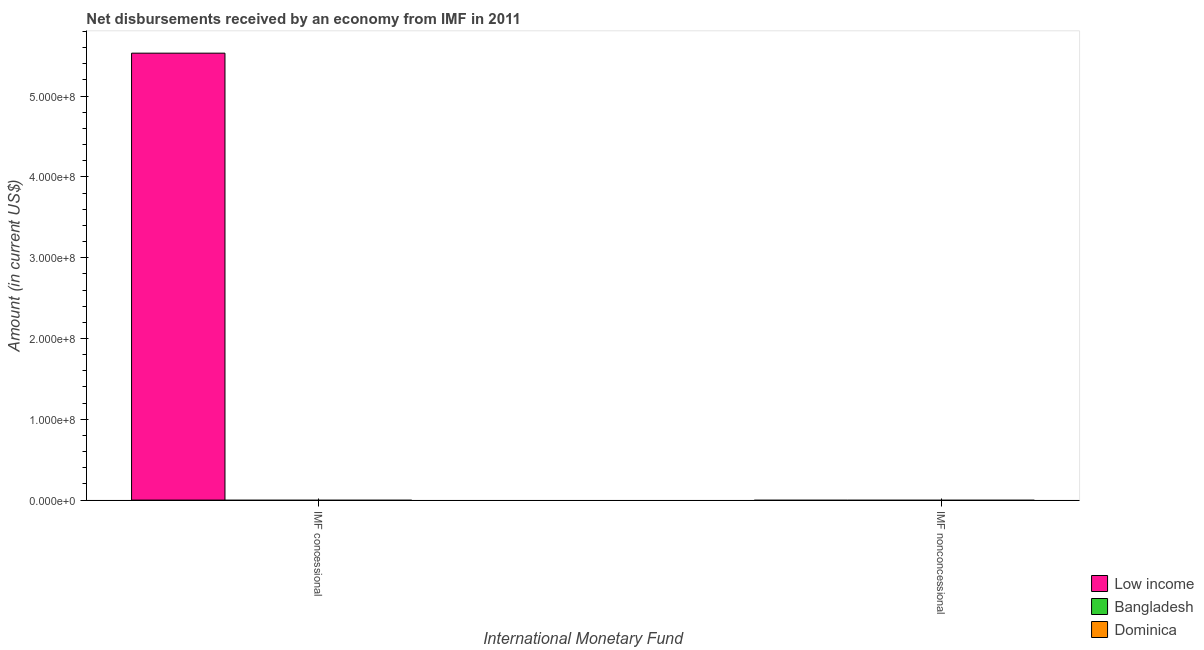How many different coloured bars are there?
Provide a short and direct response. 1. Are the number of bars per tick equal to the number of legend labels?
Give a very brief answer. No. Are the number of bars on each tick of the X-axis equal?
Give a very brief answer. No. How many bars are there on the 1st tick from the right?
Your answer should be compact. 0. What is the label of the 2nd group of bars from the left?
Provide a short and direct response. IMF nonconcessional. What is the net concessional disbursements from imf in Dominica?
Provide a succinct answer. 0. Across all countries, what is the maximum net concessional disbursements from imf?
Offer a terse response. 5.53e+08. Across all countries, what is the minimum net non concessional disbursements from imf?
Your answer should be compact. 0. What is the total net non concessional disbursements from imf in the graph?
Your answer should be compact. 0. What is the difference between the net concessional disbursements from imf in Low income and the net non concessional disbursements from imf in Bangladesh?
Ensure brevity in your answer.  5.53e+08. What is the average net concessional disbursements from imf per country?
Make the answer very short. 1.84e+08. In how many countries, is the net non concessional disbursements from imf greater than 420000000 US$?
Your answer should be compact. 0. In how many countries, is the net non concessional disbursements from imf greater than the average net non concessional disbursements from imf taken over all countries?
Provide a short and direct response. 0. How many bars are there?
Your response must be concise. 1. Are all the bars in the graph horizontal?
Your answer should be compact. No. Does the graph contain any zero values?
Keep it short and to the point. Yes. Does the graph contain grids?
Provide a succinct answer. No. How many legend labels are there?
Keep it short and to the point. 3. How are the legend labels stacked?
Provide a succinct answer. Vertical. What is the title of the graph?
Offer a very short reply. Net disbursements received by an economy from IMF in 2011. What is the label or title of the X-axis?
Give a very brief answer. International Monetary Fund. What is the Amount (in current US$) in Low income in IMF concessional?
Keep it short and to the point. 5.53e+08. What is the Amount (in current US$) in Bangladesh in IMF concessional?
Ensure brevity in your answer.  0. What is the Amount (in current US$) in Low income in IMF nonconcessional?
Provide a short and direct response. 0. What is the Amount (in current US$) of Bangladesh in IMF nonconcessional?
Give a very brief answer. 0. What is the Amount (in current US$) in Dominica in IMF nonconcessional?
Give a very brief answer. 0. Across all International Monetary Fund, what is the maximum Amount (in current US$) of Low income?
Provide a succinct answer. 5.53e+08. Across all International Monetary Fund, what is the minimum Amount (in current US$) in Low income?
Your answer should be very brief. 0. What is the total Amount (in current US$) in Low income in the graph?
Your response must be concise. 5.53e+08. What is the total Amount (in current US$) in Bangladesh in the graph?
Provide a short and direct response. 0. What is the average Amount (in current US$) of Low income per International Monetary Fund?
Provide a succinct answer. 2.77e+08. What is the average Amount (in current US$) of Dominica per International Monetary Fund?
Your answer should be compact. 0. What is the difference between the highest and the lowest Amount (in current US$) of Low income?
Make the answer very short. 5.53e+08. 